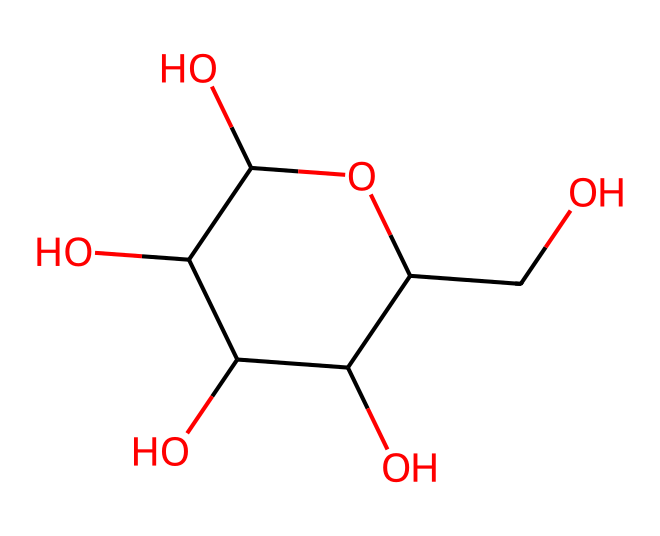What is the total number of carbon atoms in glucose? By analyzing the provided SMILES notation, we can count the carbon atoms in the structure. In the given SMILES, there are 6 carbon atoms represented by 'C' in the notation.
Answer: 6 How many hydroxyl groups (-OH) are present in glucose? In the SMILES notation, we can identify hydroxyl groups by looking for 'O' connected to a carbon atom without being part of a carbonyl (C=O). The structure shows 5 -OH groups attached to the carbon skeleton.
Answer: 5 Is glucose an aliphatic or aromatic compound? Analyzing the structure indicates that glucose has a straight-chain carbon framework and does not contain any benzene ring; therefore, it is classified as an aliphatic compound.
Answer: aliphatic What is the molecular formula of glucose? To derive the molecular formula from the SMILES, we count the atoms of each element seen: 6 carbons, 12 hydrogens, and 6 oxygens. Thus, the molecular formula is C6H12O6.
Answer: C6H12O6 How does the arrangement of functional groups affect glucose's solubility? The multiple hydroxyl groups (-OH) create hydrogen bonds with water, increasing glucose's solubility in aqueous solutions. This is particularly important for its physiological function in the body.
Answer: increases solubility Which part of the glucose molecule indicates its role in energy metabolism? The presence of multiple hydroxyl groups and its general structure indicate glucose's role as a primary energy source, as these features allow it to be easily metabolized in biological systems.
Answer: energy source What type of isomerism can glucose exhibit? Given that glucose can exist in different structural forms (such as cyclic and linear), it can exhibit structural isomerism and potentially stereoisomerism due to the different orientations of the -OH groups.
Answer: structural isomerism 